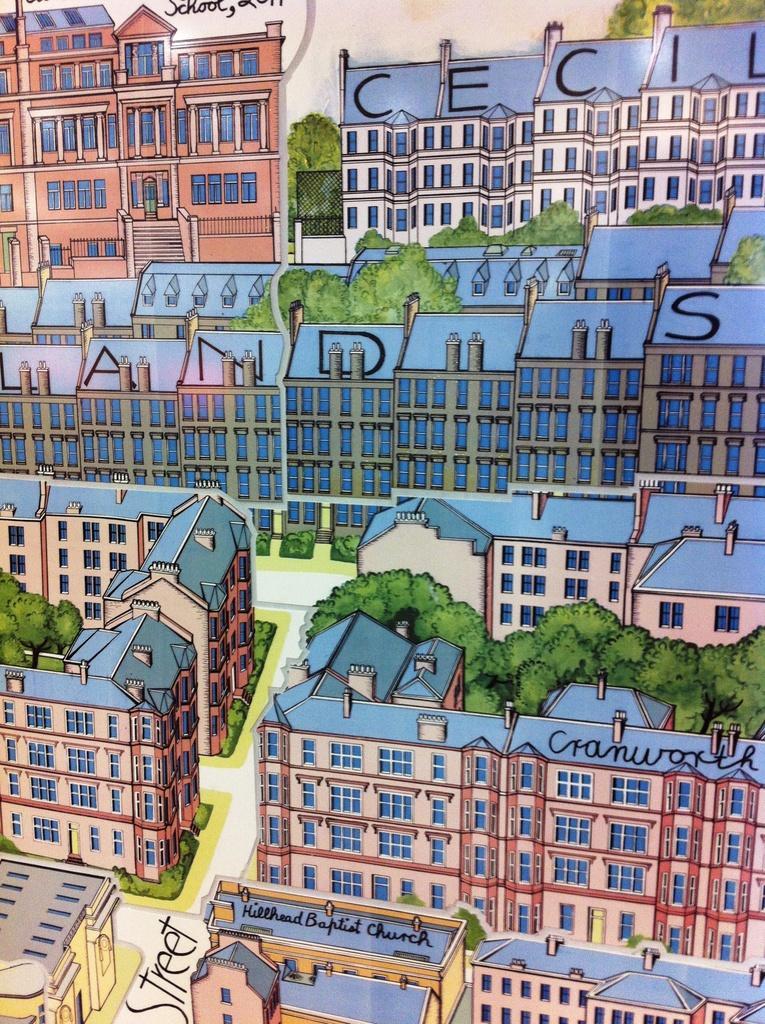Describe this image in one or two sentences. In this image I can see an art in which I can see few roads, few buildings and few trees. I can see something is written and the sky in the background. 